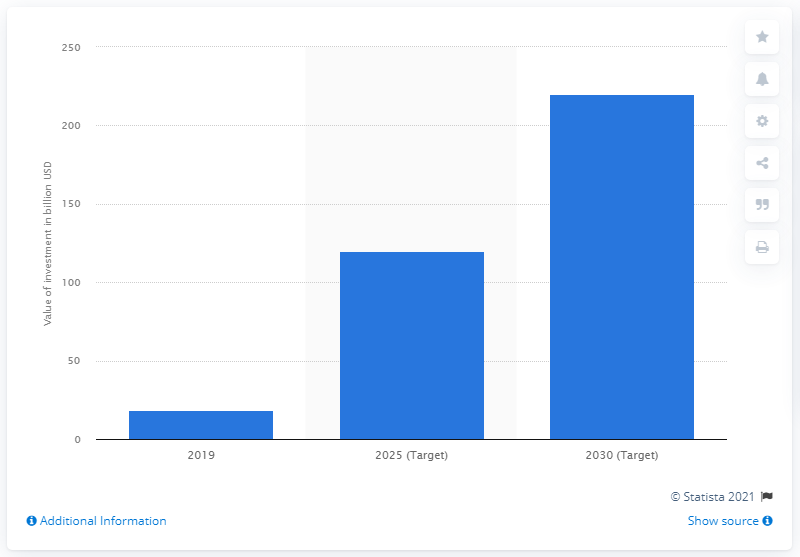Specify some key components in this picture. Banco Santander aims to achieve its goal for green finance between 2019 and 2030, which is to increase its investment in sustainable projects and reduce its carbon footprint by 50% compared to 2017 levels. Banco Santander aims to facilitate and mobilize at least 120 billion USD in green finance between 2019 and 2025. In 2019, Banco Santander achieved significant progress in the area of green finance, with a total of 18.6... 